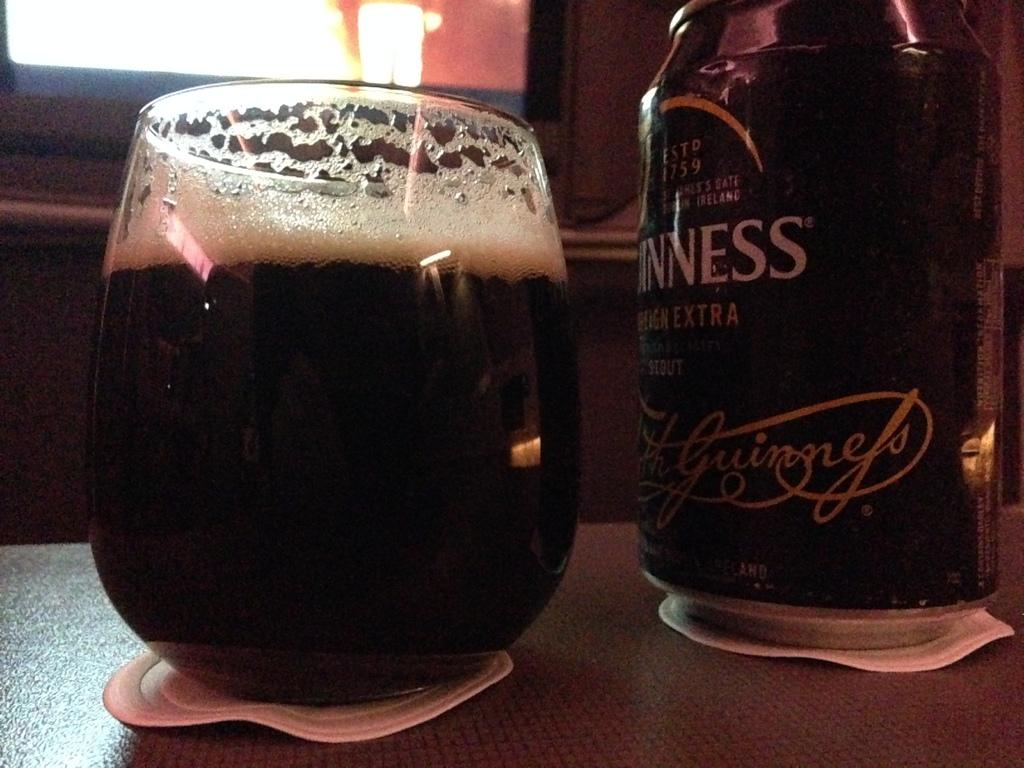Is this a bottle of guinness?
Provide a succinct answer. Yes. What brand of beer is this?
Make the answer very short. Guinness. 